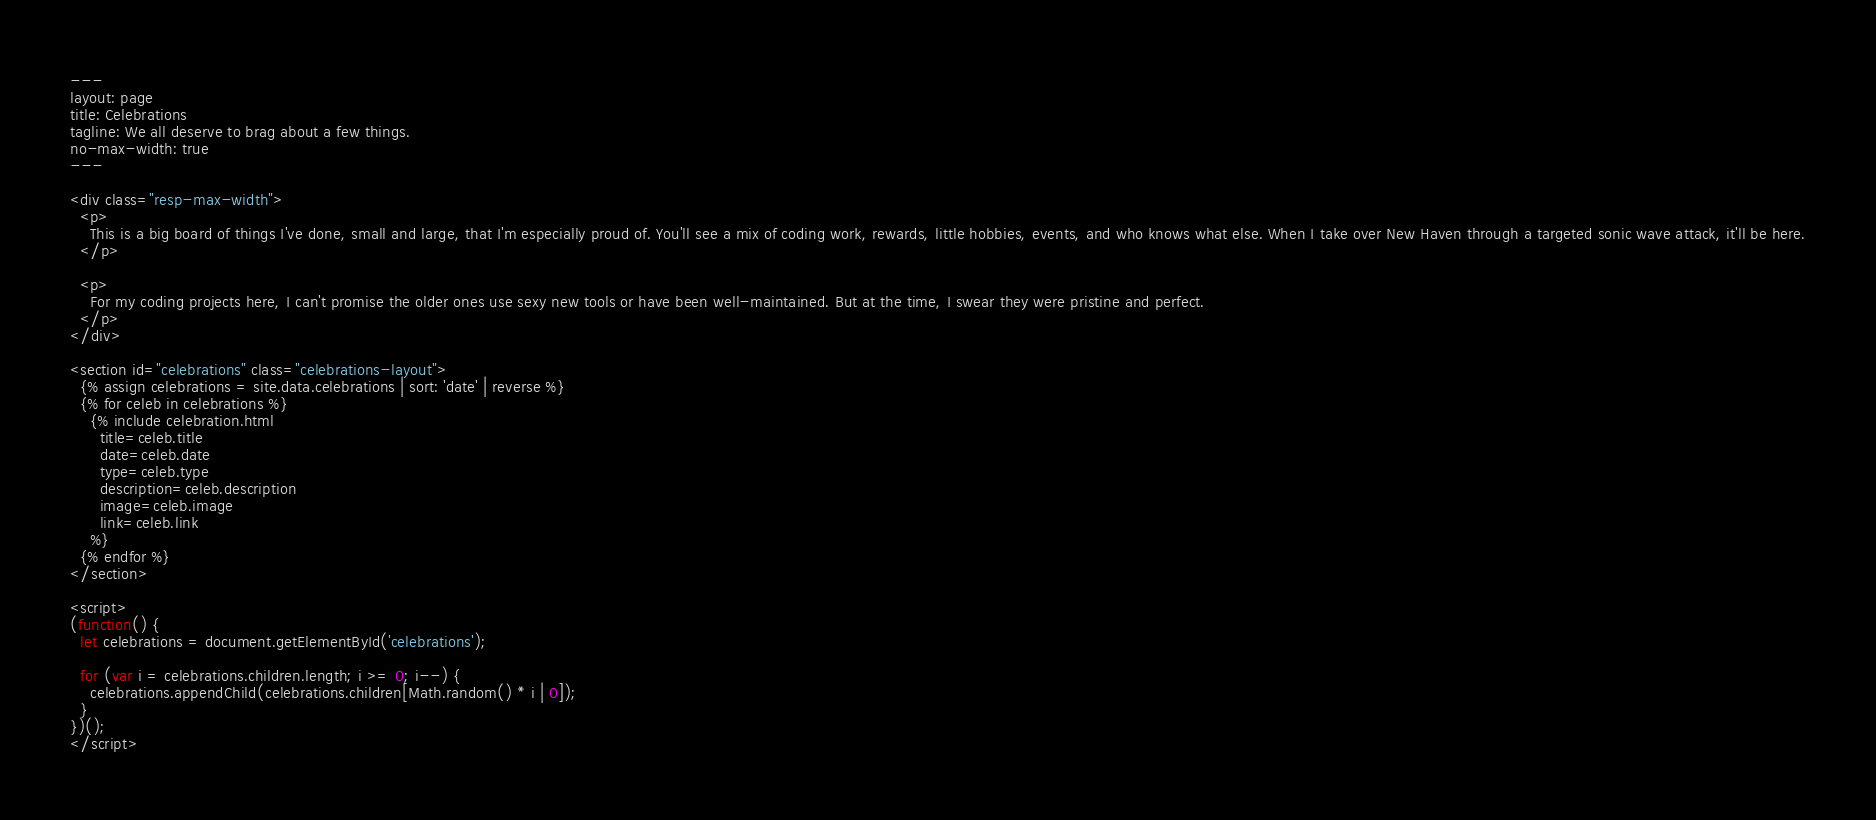<code> <loc_0><loc_0><loc_500><loc_500><_HTML_>---
layout: page
title: Celebrations
tagline: We all deserve to brag about a few things.
no-max-width: true
---

<div class="resp-max-width">
  <p>
    This is a big board of things I've done, small and large, that I'm especially proud of. You'll see a mix of coding work, rewards, little hobbies, events, and who knows what else. When I take over New Haven through a targeted sonic wave attack, it'll be here.
  </p>

  <p>
    For my coding projects here, I can't promise the older ones use sexy new tools or have been well-maintained. But at the time, I swear they were pristine and perfect.
  </p>
</div>

<section id="celebrations" class="celebrations-layout">
  {% assign celebrations = site.data.celebrations | sort: 'date' | reverse %}
  {% for celeb in celebrations %}
    {% include celebration.html
      title=celeb.title
      date=celeb.date
      type=celeb.type
      description=celeb.description
      image=celeb.image
      link=celeb.link
    %}
  {% endfor %}
</section>

<script>
(function() {
  let celebrations = document.getElementById('celebrations');

  for (var i = celebrations.children.length; i >= 0; i--) {
    celebrations.appendChild(celebrations.children[Math.random() * i | 0]);
  }
})();
</script>
</code> 